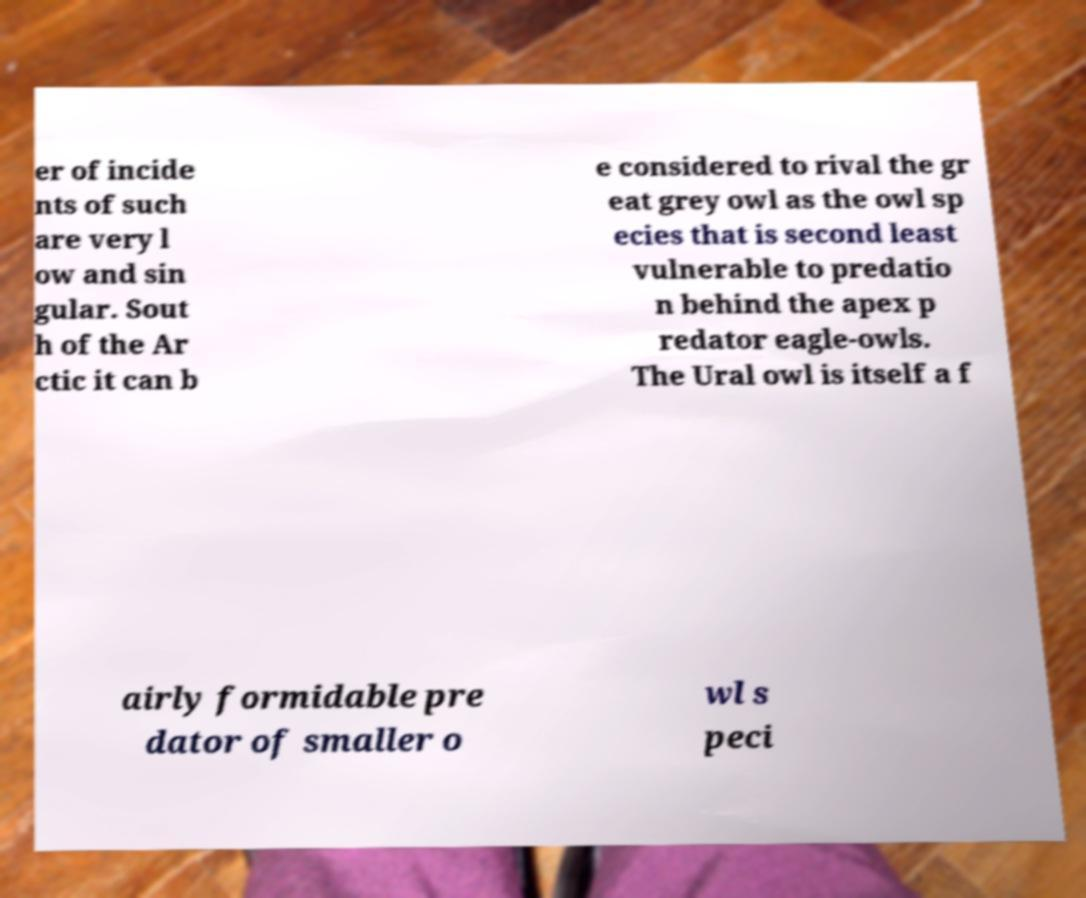Can you read and provide the text displayed in the image?This photo seems to have some interesting text. Can you extract and type it out for me? er of incide nts of such are very l ow and sin gular. Sout h of the Ar ctic it can b e considered to rival the gr eat grey owl as the owl sp ecies that is second least vulnerable to predatio n behind the apex p redator eagle-owls. The Ural owl is itself a f airly formidable pre dator of smaller o wl s peci 